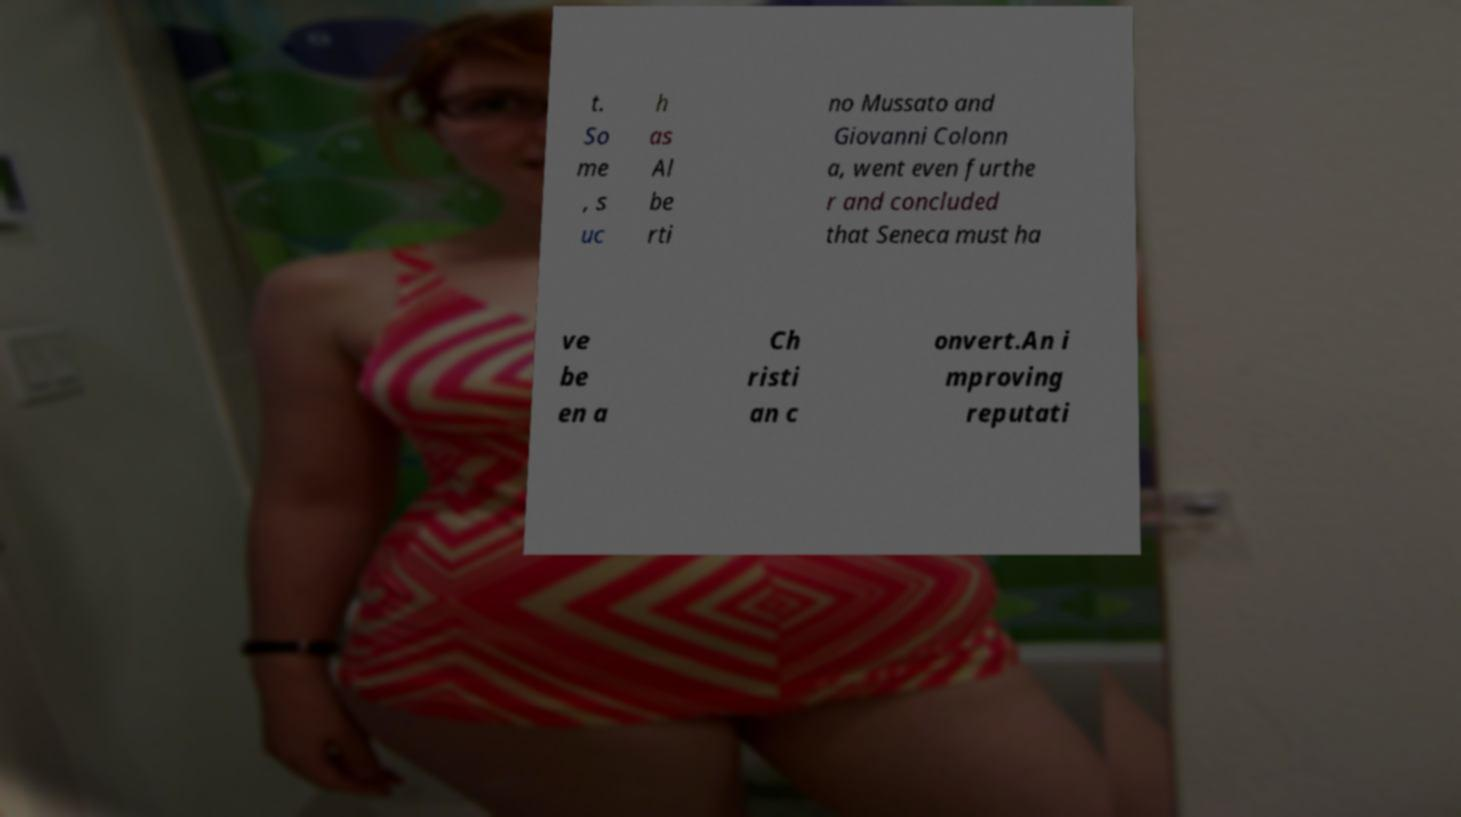Please identify and transcribe the text found in this image. t. So me , s uc h as Al be rti no Mussato and Giovanni Colonn a, went even furthe r and concluded that Seneca must ha ve be en a Ch risti an c onvert.An i mproving reputati 